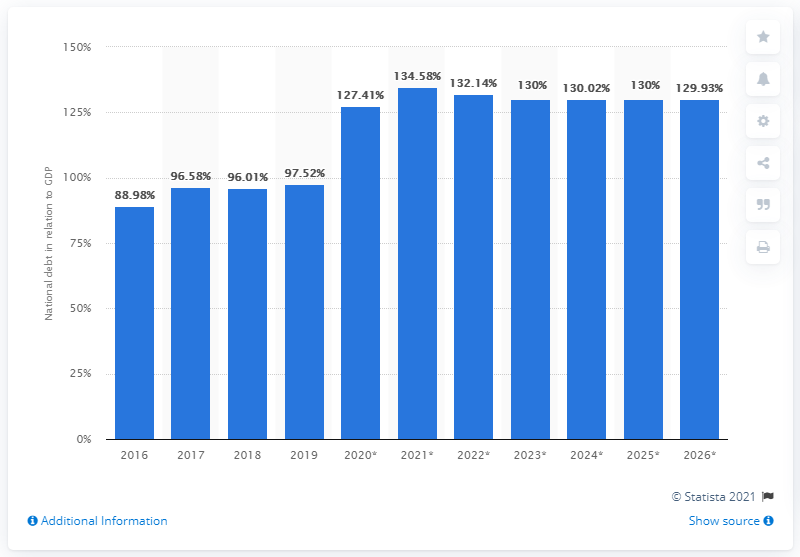Mention a couple of crucial points in this snapshot. In 2019, the national debt of Belize accounted for approximately 97.52% of the country's Gross Domestic Product (GDP). 